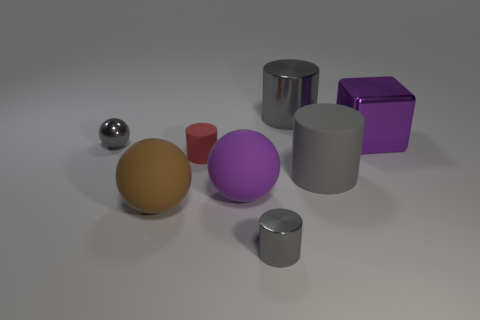Is the color of the big metal cylinder the same as the small shiny sphere?
Provide a short and direct response. Yes. Is there a large gray object that has the same shape as the big brown rubber object?
Ensure brevity in your answer.  No. There is a gray shiny thing right of the small metallic cylinder; what shape is it?
Provide a succinct answer. Cylinder. How many big brown balls are in front of the shiny cylinder in front of the cylinder that is behind the metallic cube?
Your response must be concise. 0. There is a large metallic thing on the left side of the large block; is its color the same as the block?
Keep it short and to the point. No. How many other things are the same shape as the small red rubber object?
Make the answer very short. 3. What number of other objects are there of the same material as the small gray ball?
Give a very brief answer. 3. What material is the large purple thing right of the large cylinder that is on the left side of the large gray cylinder that is right of the big gray shiny cylinder?
Offer a terse response. Metal. Does the big brown ball have the same material as the tiny gray cylinder?
Provide a succinct answer. No. How many spheres are either yellow things or purple objects?
Your answer should be very brief. 1. 